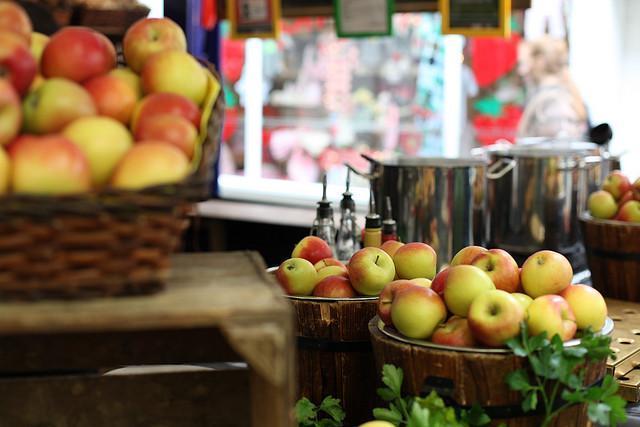How many types of fruit are there?
Give a very brief answer. 1. How many apples can be seen?
Give a very brief answer. 11. How many bowls are there?
Give a very brief answer. 3. 